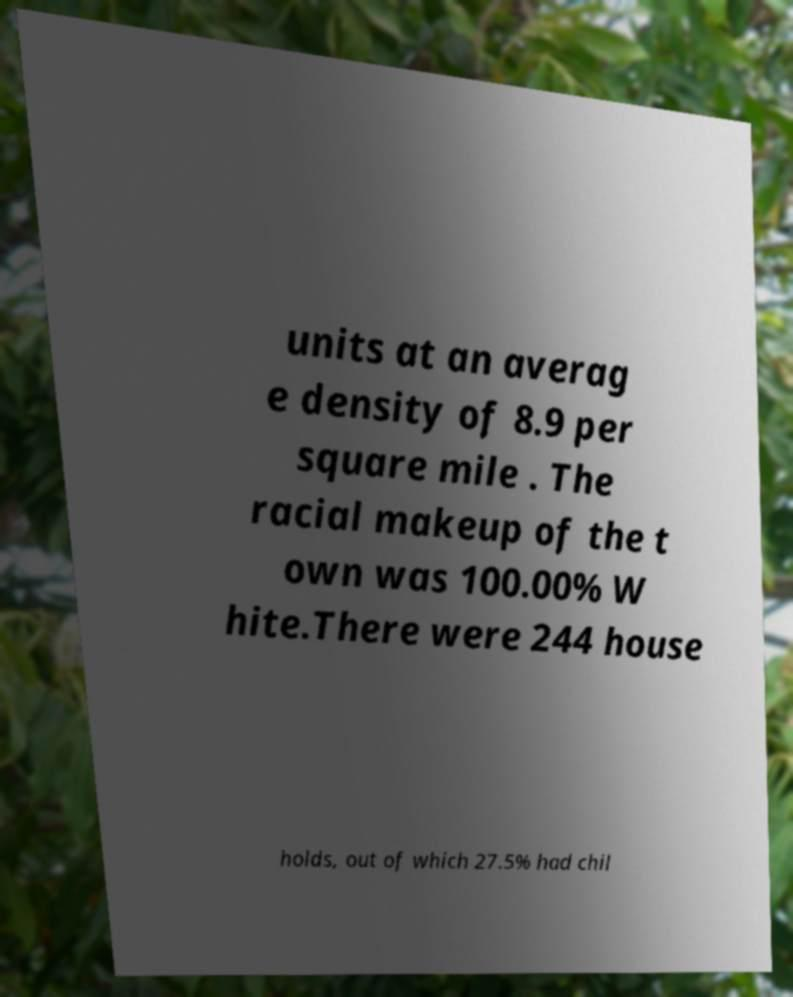Can you accurately transcribe the text from the provided image for me? units at an averag e density of 8.9 per square mile . The racial makeup of the t own was 100.00% W hite.There were 244 house holds, out of which 27.5% had chil 